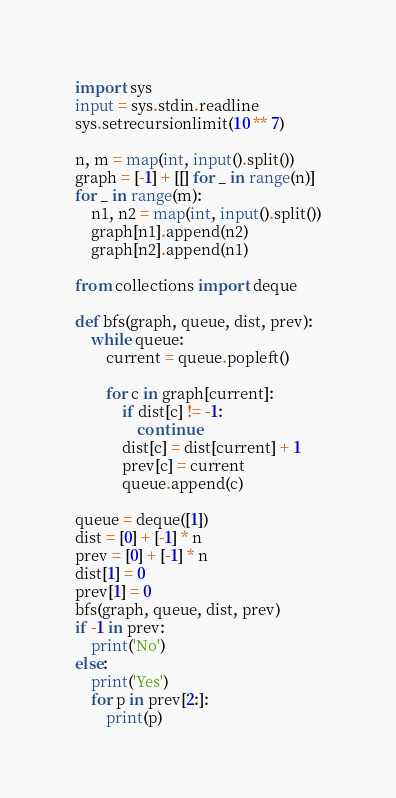<code> <loc_0><loc_0><loc_500><loc_500><_Python_>import sys
input = sys.stdin.readline
sys.setrecursionlimit(10 ** 7)

n, m = map(int, input().split())
graph = [-1] + [[] for _ in range(n)]
for _ in range(m):
    n1, n2 = map(int, input().split())
    graph[n1].append(n2)
    graph[n2].append(n1)

from collections import deque

def bfs(graph, queue, dist, prev):
    while queue:
        current = queue.popleft()

        for c in graph[current]:
            if dist[c] != -1:
                continue
            dist[c] = dist[current] + 1
            prev[c] = current
            queue.append(c)

queue = deque([1])
dist = [0] + [-1] * n
prev = [0] + [-1] * n
dist[1] = 0
prev[1] = 0
bfs(graph, queue, dist, prev)
if -1 in prev:
    print('No')
else:
    print('Yes')
    for p in prev[2:]:
        print(p)
</code> 